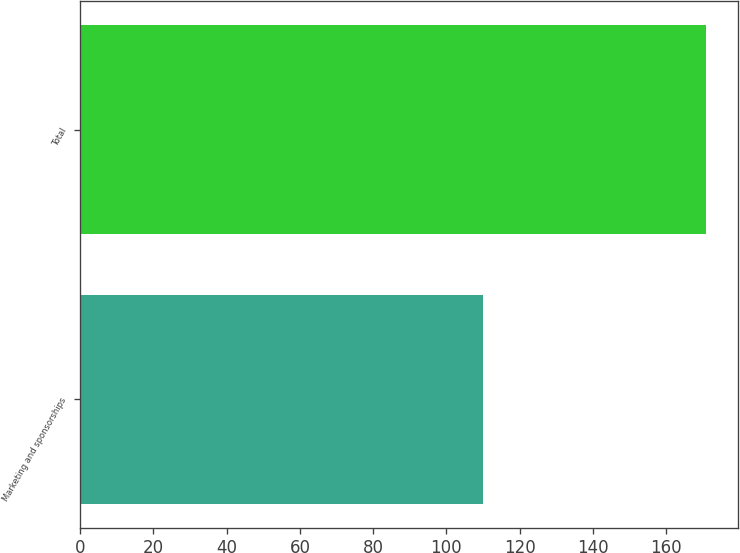Convert chart to OTSL. <chart><loc_0><loc_0><loc_500><loc_500><bar_chart><fcel>Marketing and sponsorships<fcel>Total<nl><fcel>110<fcel>171<nl></chart> 